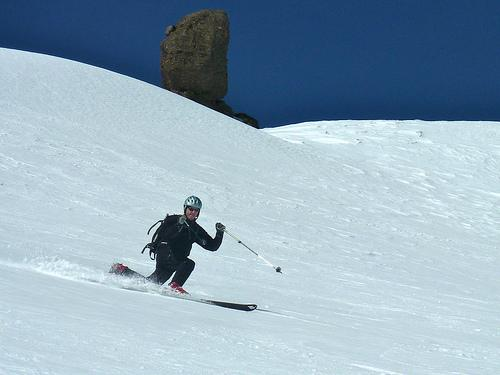Identify the key objects in the scene apart from the skier and explain their visual appearance. Apart from the skier, there are snow-covered hills, a large grey rock, a deep blue cloudless sky, and white powder snow. How many legs of the skier are visible in the image, and what color are the boots? Both legs of the skier are visible, and the ski boots are red. In a single sentence, capture the overall sentiment of the image. The image depicts an exhilarating winter day filled with adventure, as a skier enjoys the snow-covered slopes and the bright blue sky. What is the person in the image wearing on their head? The person is wearing a silver helmet on their head. Express the primary activity happening in the picture. The main activity is a man skiing down a snow-covered hill. Based on the image's components, reason about the weather and the overall atmosphere. The weather appears to be cold and sunny, with a clear and cloudless deep blue sky, which creates an ideal skiing atmosphere on the snow-covered hill. Analyze the quality of the image, considering factors such as clarity, color, and composition. The image quality is quite good, featuring clear and crisp details, vibrant colors, and well-balanced composition that showcases the main subject effectively. Examine the image and provide insights on how the person's ski attire might protect him from the cold environment. The skier is wearing ski clothing such as a helmet, polarized sunglasses, a black ski jacket, and pants that offer protection against the cold and ensure safety while skiing. Describe any possible interactions between the objects in the scene. The skier is moving down the snow-covered hill amidst the large rocks while holding a ski pole in his hand and wearing ski gear that helps him interact with the snowy environment effectively. Which of the following items is worn by the skier: sunglasses, scarf, or sunglasses and scarf? Sunglasses. Is there any object on top of the hill shown in the picture? Yes, there is a large grey rock at the top of the hill. Point out the elements in the image that describe a sunny day. A deep blue cloudless sky and white powder snow on the ground. What is the color of the skier's helmet? The ski helmet is silver. Which object is being used by the man to propel himself while skiing? A ski pole. What color are the skier's boots? The skier's boots are red. Describe the boundaries of the snow-covered hills in the image. X:1 Y:44 Width:496 Height:496 Identify any unusual elements in this image. There are no unusual elements in the image. Is the skier using any protective gear? Yes, he is wearing a silver helmet and polarized sunglasses for safety. Are there any animals or non-human living beings in the image? No, there are no animals or non-human living beings in the image. How is the man skiing interacting with the ski pole? He is using the ski pole to propel himself while skiing. Find the emotion or sentiment conveyed by the image. The image conveys a sense of adventure and excitement. What is the weather condition in the image? A sunny, clear day with white powder snow. Can you describe the color of the sky and the presence of clouds in the image? The sky is deep blue and cloudless. Is there any text or writing visible in the image? No, there is no text or writing visible in the image. Describe the interaction between the man and the ski pole in the image. The man is holding the ski pole in his left hand, using it to propel himself while skiing. Describe the main elements in the image. A man skiing, snow covered hills, a large grey rock, and a deep blue cloudless sky. Identify the primary outdoor activities taking place in the image. Skiing and snowboarding. Point out the image's elements that signify it is a sunny day. The beautiful blue sky and no clouds. 